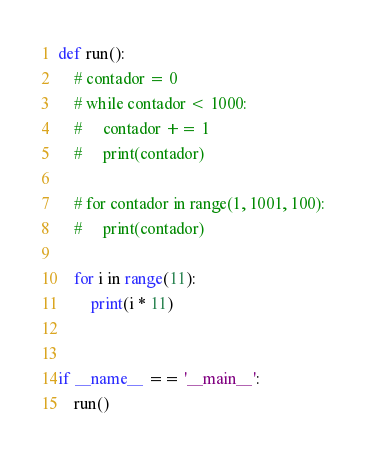<code> <loc_0><loc_0><loc_500><loc_500><_Python_>def run():
    # contador = 0
    # while contador < 1000:
    #     contador += 1
    #     print(contador)

    # for contador in range(1, 1001, 100):
    #     print(contador)

    for i in range(11):
        print(i * 11)


if __name__ == '__main__':
    run()
</code> 